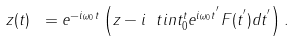Convert formula to latex. <formula><loc_0><loc_0><loc_500><loc_500>z ( t ) \ = e ^ { - i \omega _ { 0 } t } \left ( z - i \ t i n t _ { 0 } ^ { t } e ^ { i \omega _ { 0 } t ^ { ^ { \prime } } } F ( t ^ { ^ { \prime } } ) d t ^ { ^ { \prime } } \right ) . \text {\ }</formula> 